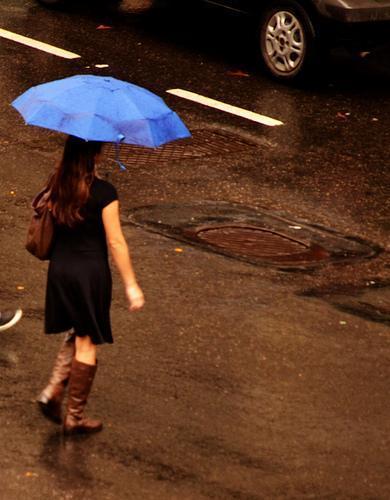How many legs are touching the ground?
Give a very brief answer. 1. 